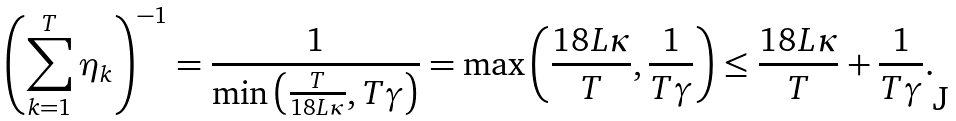<formula> <loc_0><loc_0><loc_500><loc_500>\left ( \sum _ { k = 1 } ^ { T } \eta _ { k } \right ) ^ { - 1 } = \frac { 1 } { \min \left ( \frac { T } { 1 8 L \kappa } , T \gamma \right ) } = \max \left ( \frac { 1 8 L \kappa } { T } , \frac { 1 } { T \gamma } \right ) \leq \frac { 1 8 L \kappa } { T } + \frac { 1 } { T \gamma } .</formula> 